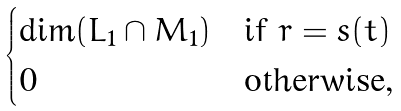Convert formula to latex. <formula><loc_0><loc_0><loc_500><loc_500>\begin{cases} \dim ( L _ { 1 } \cap M _ { 1 } ) & \text {if } r = s ( t ) \\ 0 & \text {otherwise,} \end{cases}</formula> 